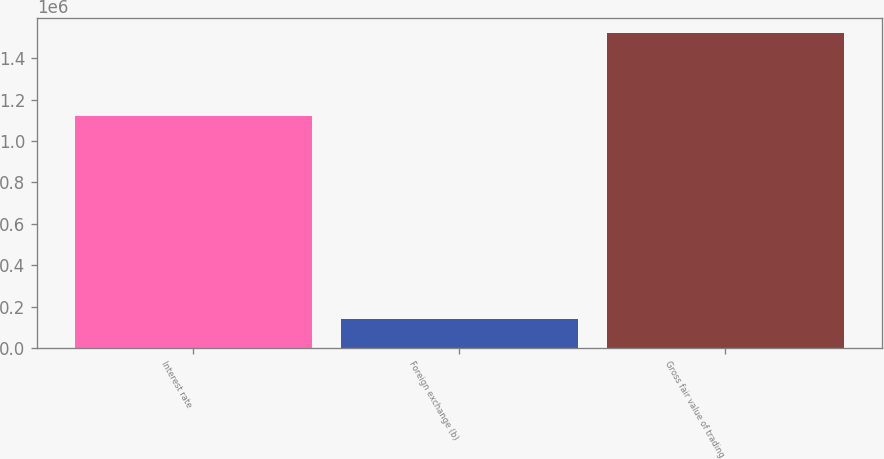Convert chart. <chart><loc_0><loc_0><loc_500><loc_500><bar_chart><fcel>Interest rate<fcel>Foreign exchange (b)<fcel>Gross fair value of trading<nl><fcel>1.1224e+06<fcel>138218<fcel>1.51918e+06<nl></chart> 